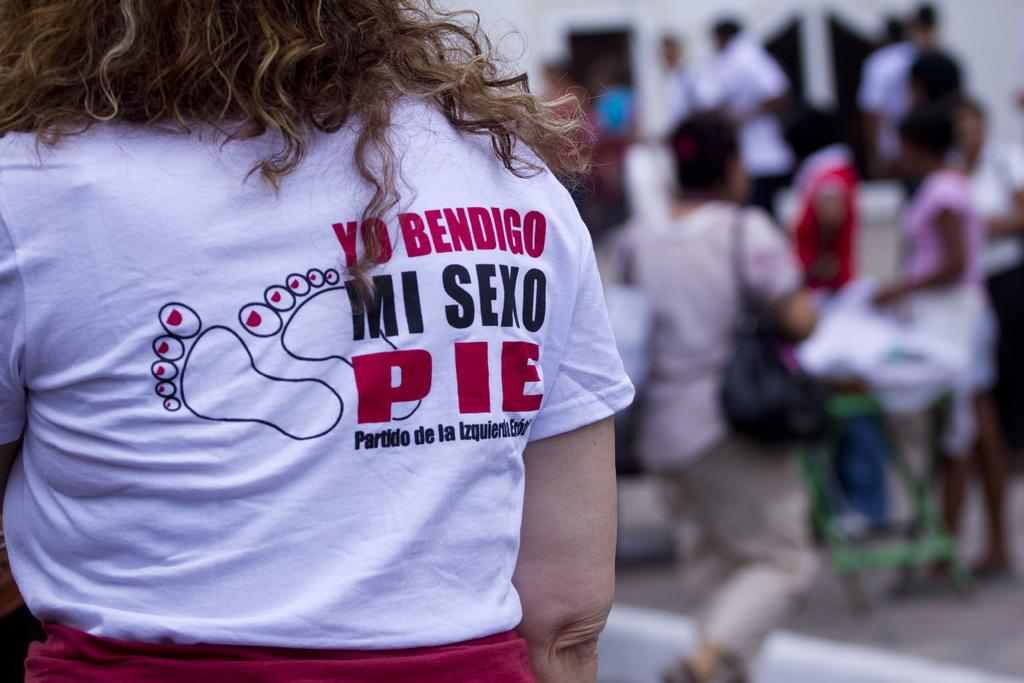Who is the main subject in the image? There is a woman in the image. What is the woman wearing? The woman is wearing a white t-shirt. Where is the woman standing? The woman is standing on a path. What can be seen in front of the woman? There are groups of people in front of the woman. Are there any unclear or blurred elements in the image? Yes, there are some blurred items in the image. How many cats are sitting on the woman's shoulders in the image? There are no cats present in the image. What type of dinosaur can be seen walking behind the woman in the image? There are no dinosaurs present in the image. 